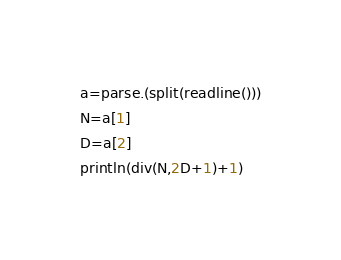<code> <loc_0><loc_0><loc_500><loc_500><_Julia_>a=parse.(split(readline()))
N=a[1]
D=a[2]
println(div(N,2D+1)+1)</code> 